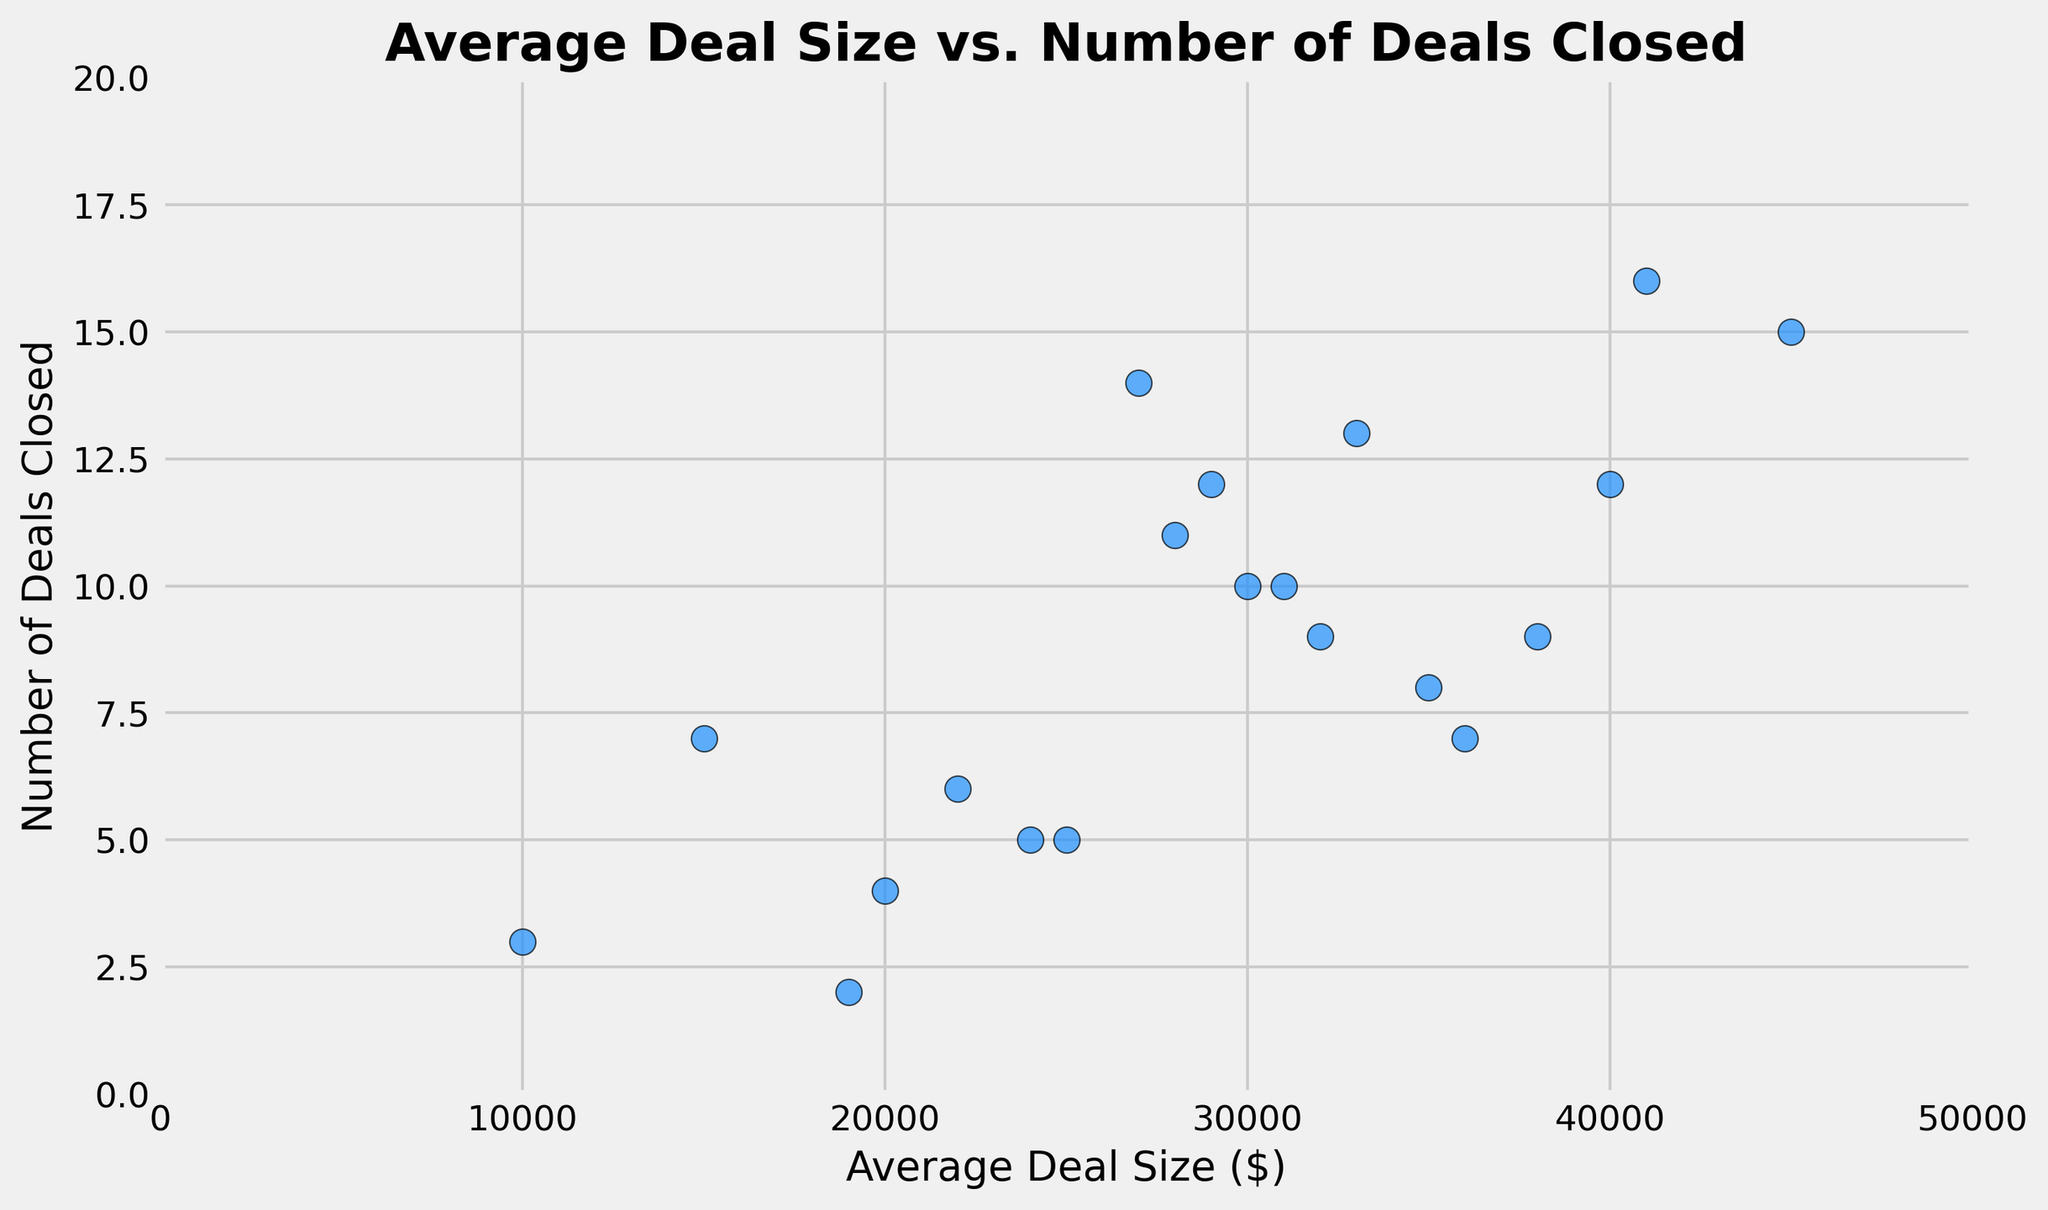What is the maximum number of deals closed by a salesperson? The maximum number of deals closed can be directly seen from the y-axis of the scatter plot. Look for the highest point along the y-axis to find the maximum value. In this case, it's 16.
Answer: 16 Is there a correlation between average deal size and the number of deals closed? To determine if there's a correlation, observe the overall trend of the points. If the points create a discernible pattern, such as upward or downward slope, there is a correlation. Here, the scatter plot shows an upward trend, indicating a positive correlation.
Answer: Yes, there is a positive correlation Which salesperson has the smallest average deal size and how many deals did they close? Identify the point with the smallest x-axis value, which represents the smallest average deal size. The point at (10000, 3) represents this value.
Answer: 3 deals What is the average number of deals closed by salespersons with an average deal size above $30,000? First, identify the points with x-values greater than $30,000. These points are: (31000, 10), (32000, 9), (33000, 13), (35000, 8), (36000, 7), (38000, 9), (40000, 12), (41000, 16), (45000, 15). Add the y-values of these points: 10 + 9 + 13 + 8 + 7 + 9 + 12 + 16 + 15 = 99. Divide this sum by the number of points, which is 9. So, 99 / 9 = 11.
Answer: 11 How does the variability in average deal size compare to the variability in number of deals closed? Look for the spread of points along the x-axis (average deal size) and y-axis (number of deals closed). The x-axis values range from $10,000 to $45,000, a range of $35,000. The y-axis values range from 2 to 16, a range of 14. The variability in average deal size (range of $35,000) is larger compared to the variability in the number of deals closed (range of 14).
Answer: The variability in average deal size is larger Are there any outliers in terms of average deal size or number of deals closed? Outliers are points that stand apart from the rest of the data. Observe if any points are significantly distant from the cluster of points. The points appear relatively clustered without any extreme values; thus, there do not seem to be any outliers visually.
Answer: No What's the combined average deal size for salespersons who closed exactly 10 deals? Identify the points with a y-value of 10: (30000, 10), (31000, 10). Add their x-values: 30000 + 31000 = 61000. Divide this sum by the number of such points, which is 2. So, 61000 / 2 = 30500.
Answer: $30,500 How many salespersons closed more than 10 deals? Count the number of points with y-values greater than 10. These points are: (27000, 14), (33000, 13), (41000, 16), (45000, 15). There are 4 such points.
Answer: 4 